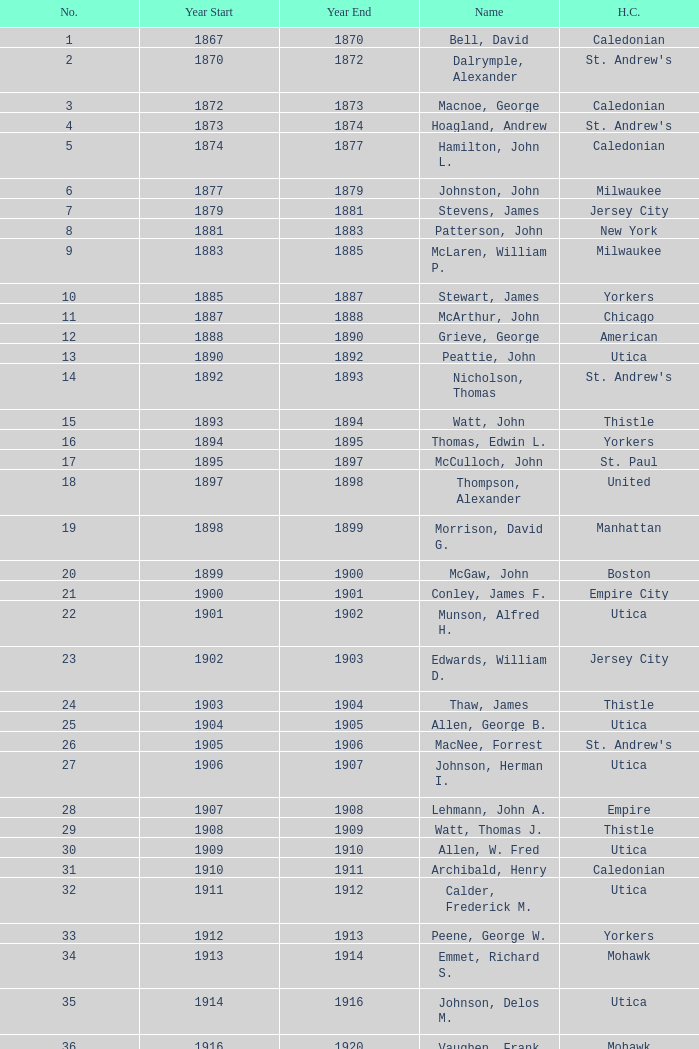Which Year Start has a Number of 28? 1907.0. 